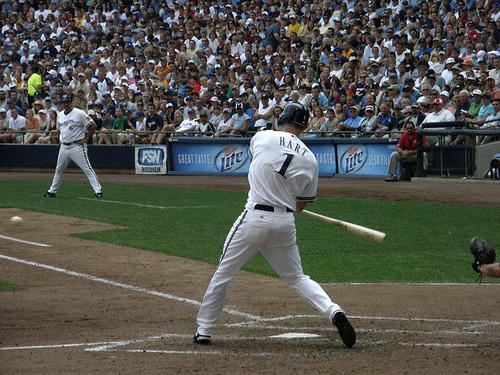Is the game sold out?
Short answer required. Yes. What number is the batter?
Short answer required. 1. What company has an ad in the background?
Be succinct. Miller lite. What sport is this?
Keep it brief. Baseball. What is the name of the batter?
Keep it brief. Hart. 